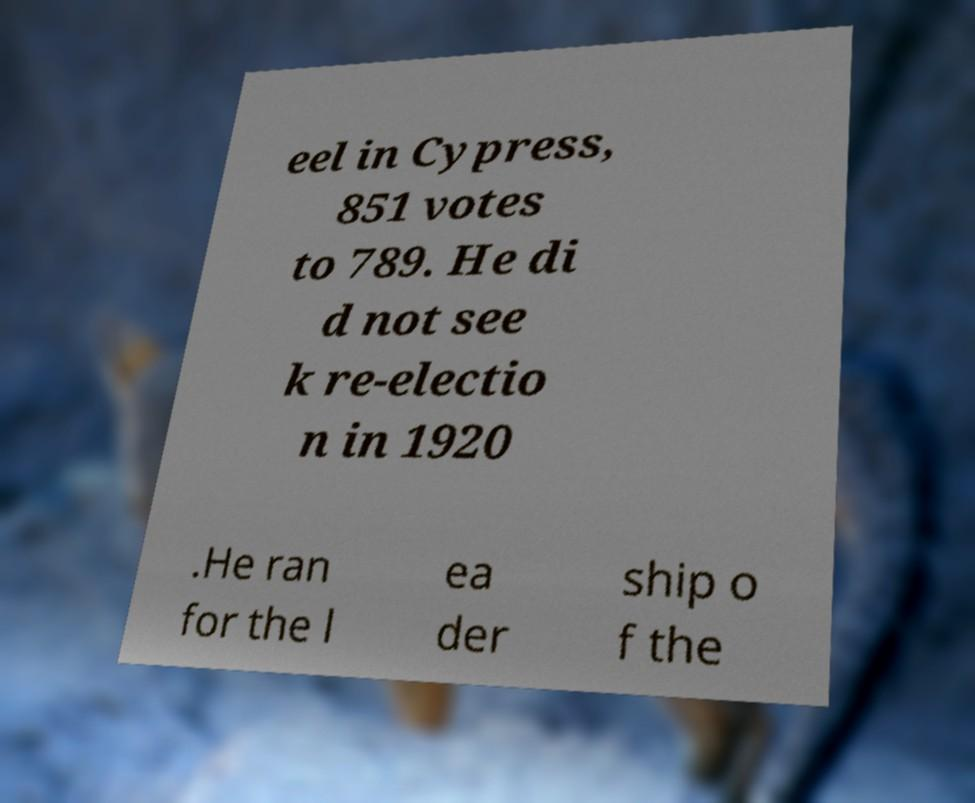Can you accurately transcribe the text from the provided image for me? eel in Cypress, 851 votes to 789. He di d not see k re-electio n in 1920 .He ran for the l ea der ship o f the 